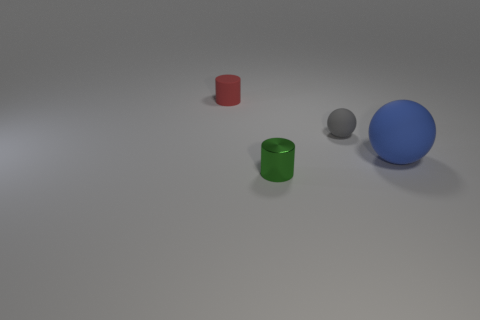Add 4 large green matte things. How many objects exist? 8 Add 1 brown matte things. How many brown matte things exist? 1 Subtract 0 brown cubes. How many objects are left? 4 Subtract all small green things. Subtract all large metallic balls. How many objects are left? 3 Add 4 red matte things. How many red matte things are left? 5 